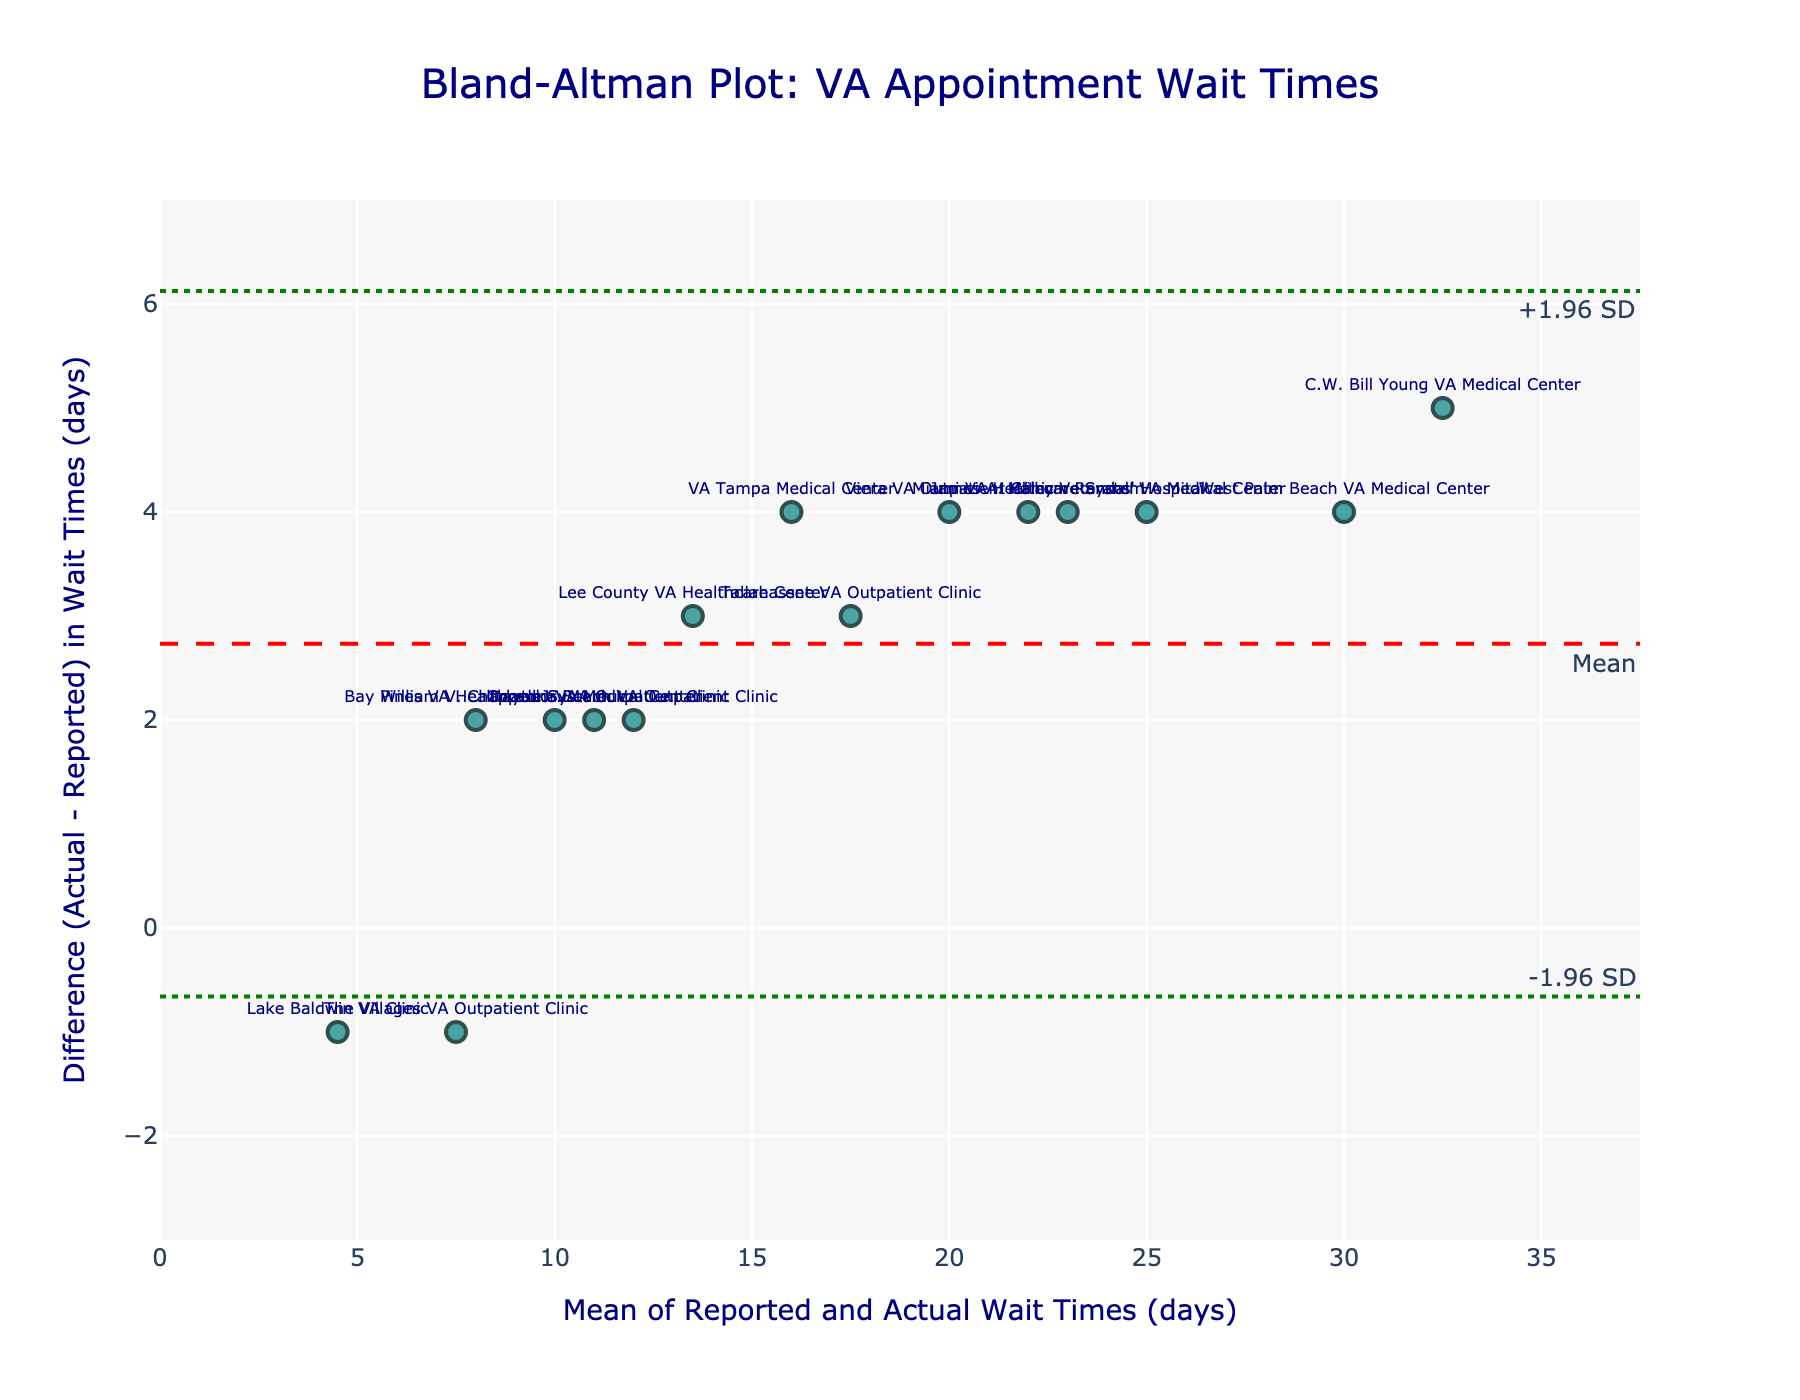What's the title of the figure? The title of a Bland-Altman plot is usually found at the top, centered and larger in font size compared to other text elements.
Answer: Bland-Altman Plot: VA Appointment Wait Times What is the x-axis title? The x-axis title typically appears below the x-axis line, describing what the x-axis represents.
Answer: Mean of Reported and Actual Wait Times (days) How many data points are in the plot? By counting the distinct markers on the plot, we can determine the number of data points.
Answer: 15 Which facility has the highest difference between actual and reported wait times? Look for the data point that is highest on the y-axis; this will have the largest positive difference.
Answer: C.W. Bill Young VA Medical Center What is the mean difference in wait times? The mean difference is depicted by the dashed red line annotated as "Mean," which runs horizontally across the plot.
Answer: 2.2 days What are the upper and lower limits of agreement? The upper and lower limits are indicated by the dotted green lines annotated as "+1.96 SD" and "-1.96 SD."
Answer: Upper: 4.83 days, Lower: -0.43 days What is the range of the x-axis? The range of the x-axis is established by the minimum and maximum values, which can be observed from the plot’s axis labels.
Answer: 0 to 35 days Which facility shows no difference in wait times? Identify the point on the plot where the y-value (difference) equals zero.
Answer: Lake Baldwin VA Clinic Which facility is furthest below the mean difference line? Look for the point that is lowest relative to the dashed red line marking the mean difference.
Answer: The Villages VA Outpatient Clinic What is the range of the differences in wait times on the y-axis? The range of the y-axis is determined by the minimum and maximum differences displayed on the plotted y-axis.
Answer: -1 to 5 days 